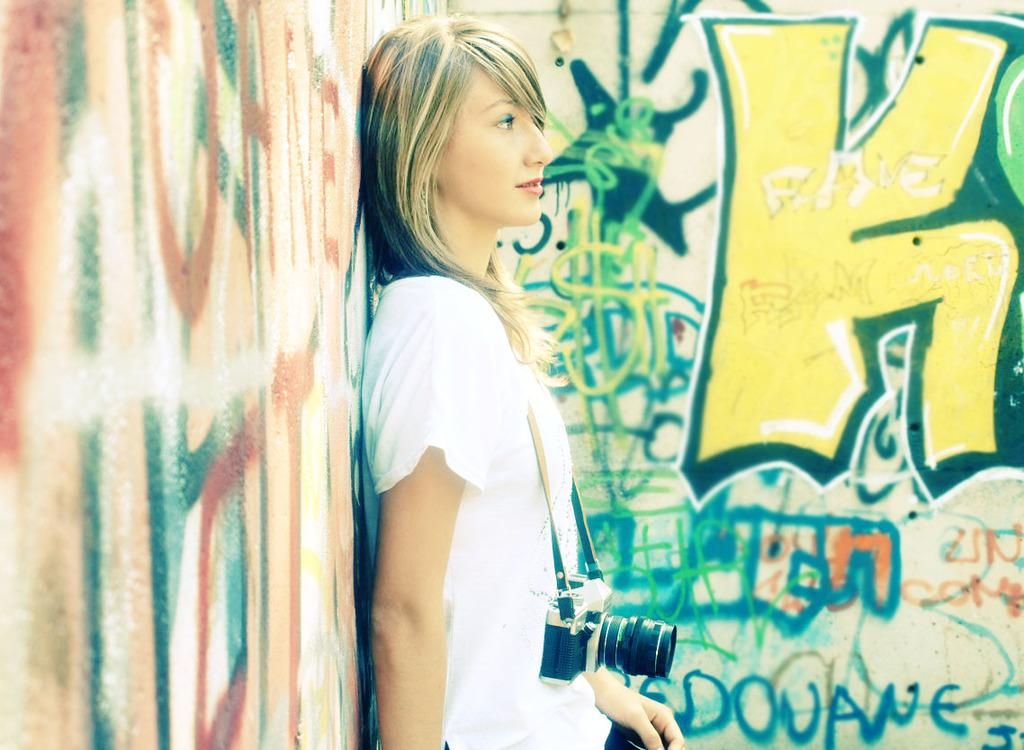Who is the main subject in the image? There is a woman in the image. What is the woman holding in the image? The woman is holding a camera. What can be seen on the walls around the woman? There are scribbles on the walls on both the left and right sides of the woman. Can you tell me what type of match the woman is holding in the image? There is no match present in the image; the woman is holding a camera. What type of cabbage can be seen on the tray in the image? There is no cabbage or tray present in the image. 